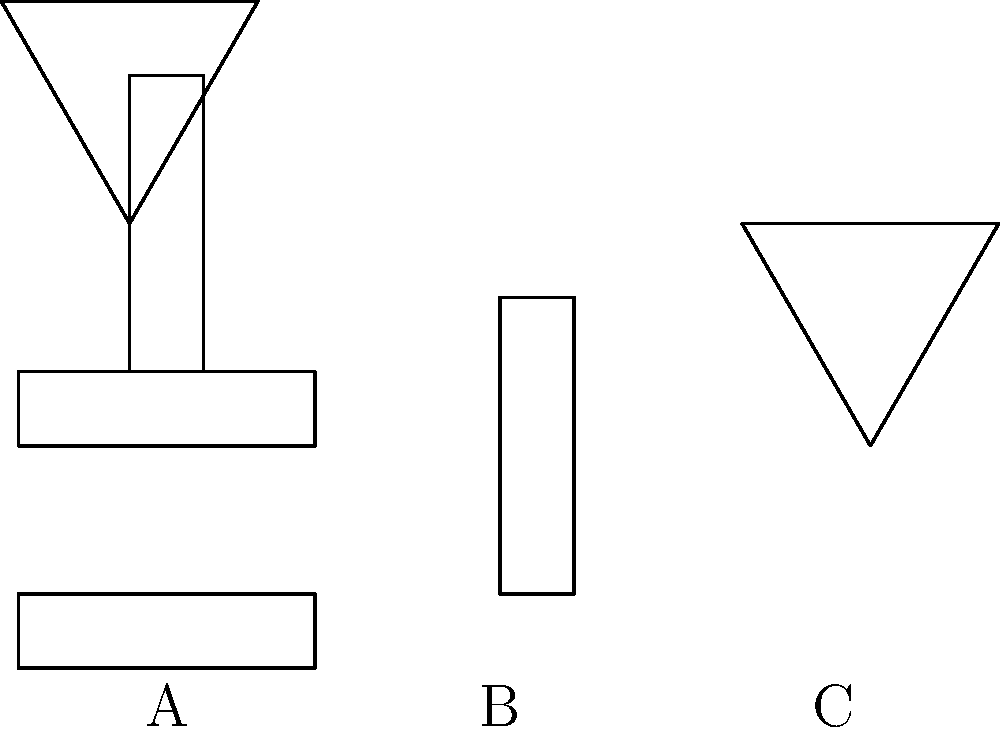As a patent attorney, you're reviewing a new invention consisting of three main components: A, B, and C. Based on the disassembled parts shown in the lower half of the image, which of the following best represents the fully assembled invention? To visualize the assembled form of the invention, we need to analyze each component and their potential connections:

1. Component A: This appears to be a rectangular base, likely serving as the foundation of the invention.

2. Component B: This is a vertical rectangular piece, possibly a shaft or support structure.

3. Component C: This is a triangular piece, which could be the top or head of the invention.

To assemble these components:

1. Start with component A as the base.
2. Component B should be placed vertically on top of A, centered along its width.
3. Component C should be positioned at the top of B, with its base aligned with the top of B.

The upper half of the image shows the correct assembly:

1. The rectangular base (A) is at the bottom.
2. The vertical shaft (B) is centered on top of the base.
3. The triangular head (C) is positioned at the top of the shaft.

This assembled form resembles a simple tool or instrument, potentially a type of press or stamp, which is a common subject in patent applications.
Answer: The upper half of the image 